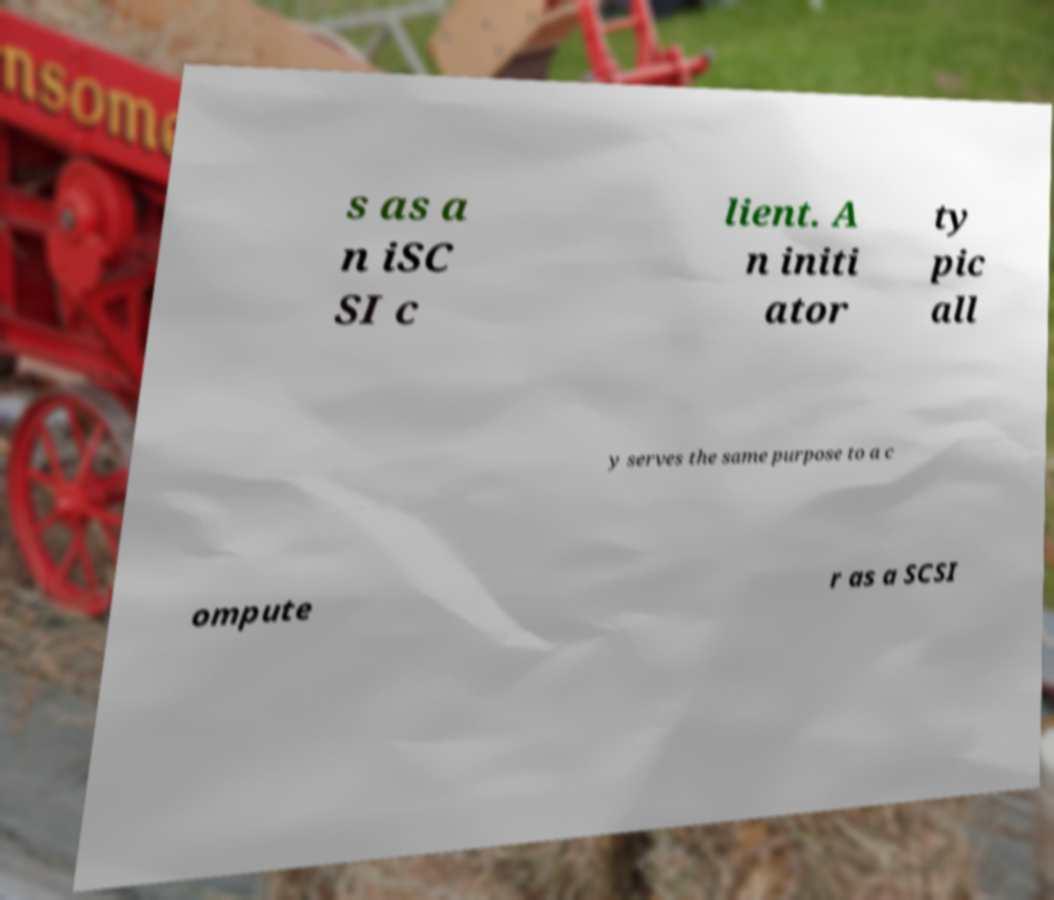There's text embedded in this image that I need extracted. Can you transcribe it verbatim? s as a n iSC SI c lient. A n initi ator ty pic all y serves the same purpose to a c ompute r as a SCSI 